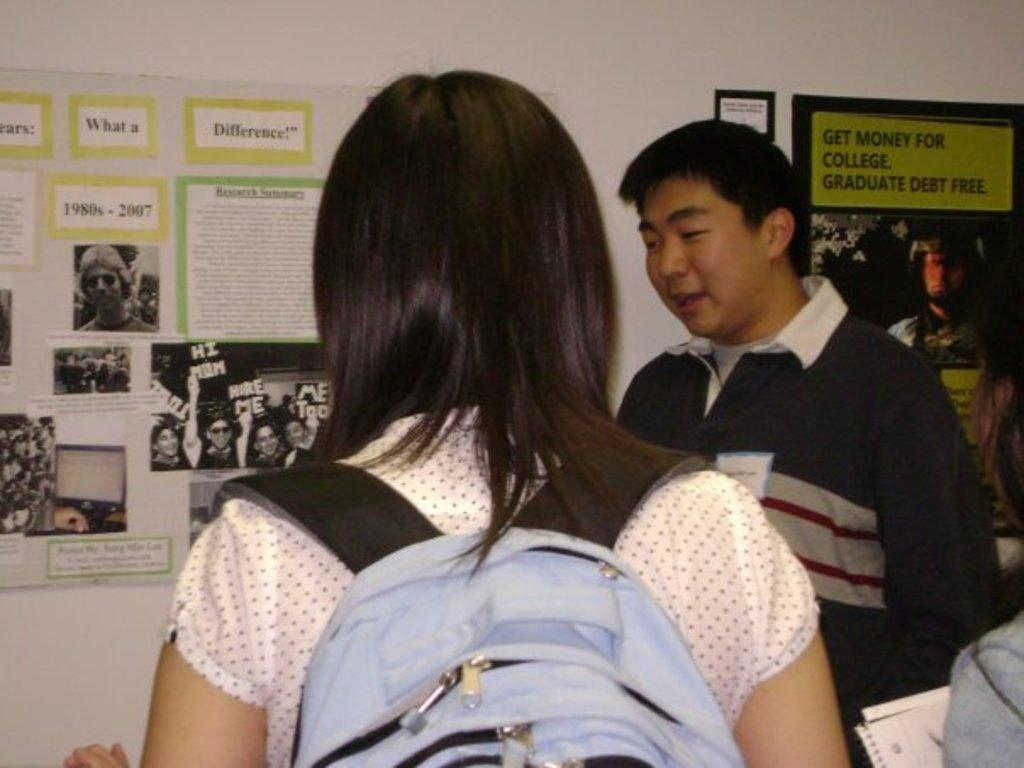What is happening in the image? There are people standing in the image. What can be seen in the background of the image? There is a wall in the background of the image. What is on the wall? There are posters on the wall. What is written on the posters? The posters contain text. What type of power source is depicted in the image? There is no power source depicted in the image; it features people standing and posters on a wall. What kind of yam is being used to write on the posters? There are no yams present in the image, and yams are not used for writing. 